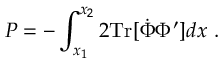Convert formula to latex. <formula><loc_0><loc_0><loc_500><loc_500>P = - \int _ { x _ { 1 } } ^ { x _ { 2 } } 2 T r [ \dot { \Phi } \Phi ^ { \prime } ] d x \ .</formula> 